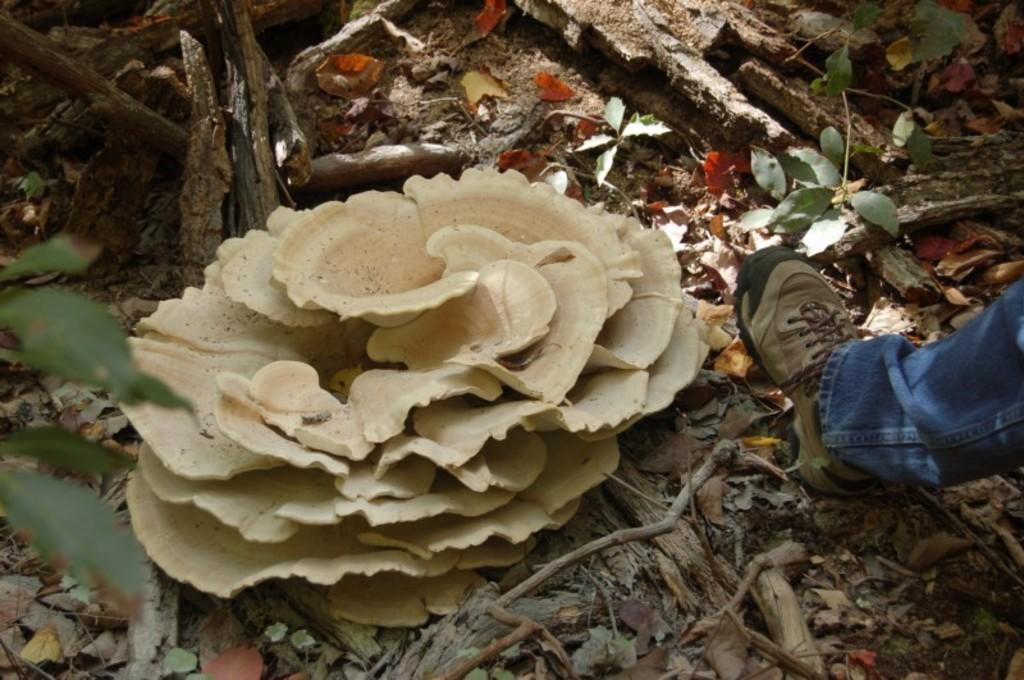How would you summarize this image in a sentence or two? In this image in the center there is a mushroom, and on the right side of the image there is one person's leg is visible and the person is wearing a shoe. And at the bottom there are some dry leaves, wooden sticks and some grass. 